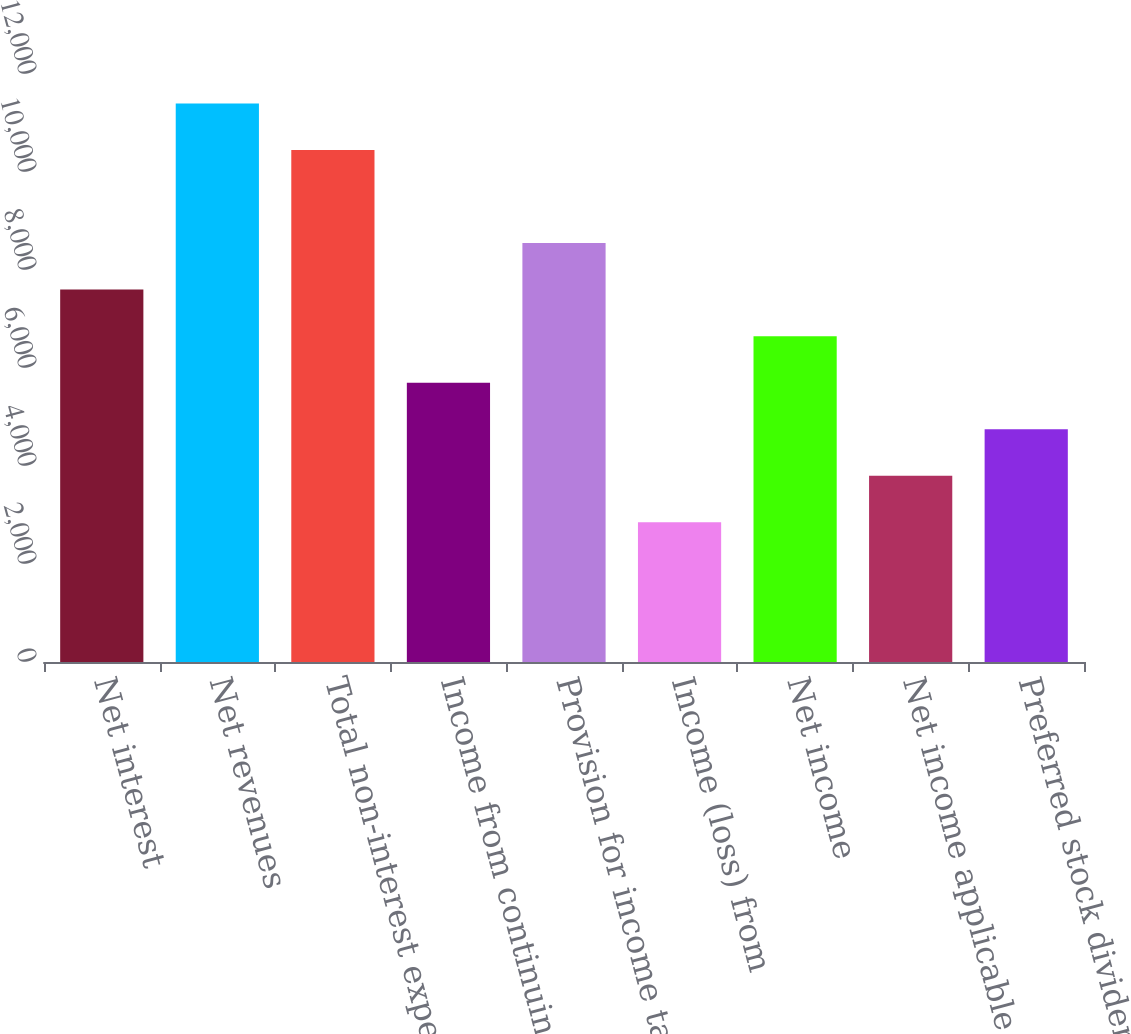Convert chart to OTSL. <chart><loc_0><loc_0><loc_500><loc_500><bar_chart><fcel>Net interest<fcel>Net revenues<fcel>Total non-interest expenses<fcel>Income from continuing<fcel>Provision for income taxes<fcel>Income (loss) from<fcel>Net income<fcel>Net income applicable to<fcel>Preferred stock dividends and<nl><fcel>7600.06<fcel>11400<fcel>10450<fcel>5700.1<fcel>8550.03<fcel>2850.18<fcel>6650.08<fcel>3800.15<fcel>4750.12<nl></chart> 